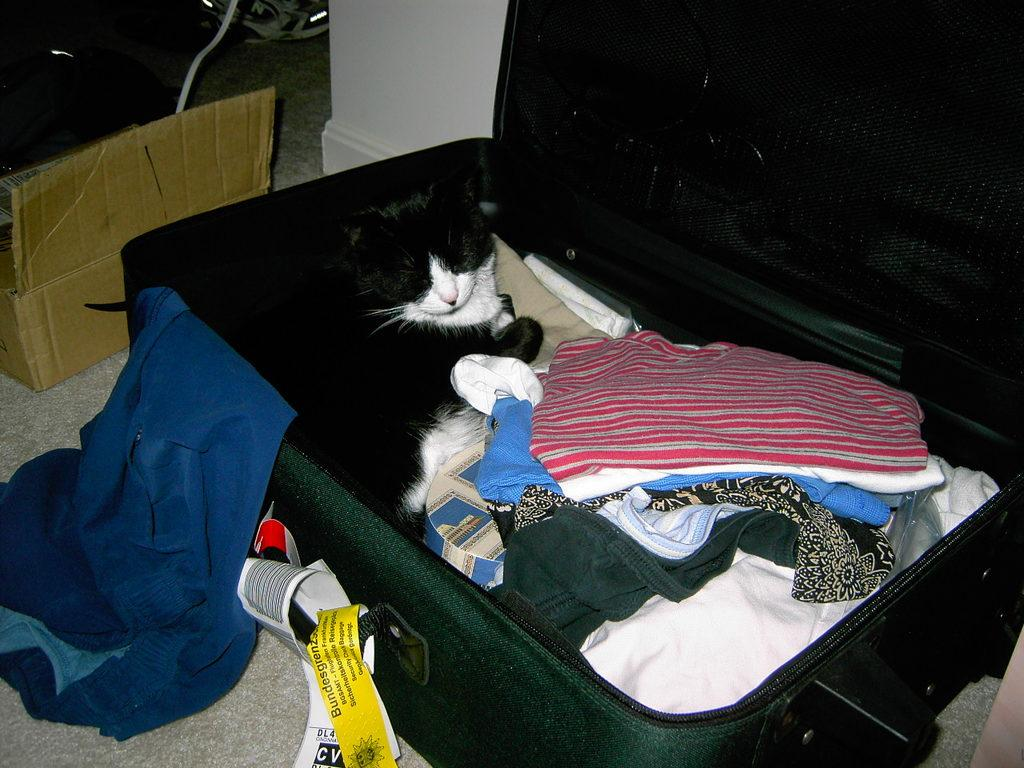What type of animal is in the image? There is a cat in the image. What is the cat lying on? The cat is lying on clothes. Where are the clothes located? The clothes are in a suitcase. What can be seen attached to the clothes or suitcase? There are tags visible in the image. What type of card is the writer holding in the image? There is no writer or card present in the image; it only features a cat lying on clothes in a suitcase. 